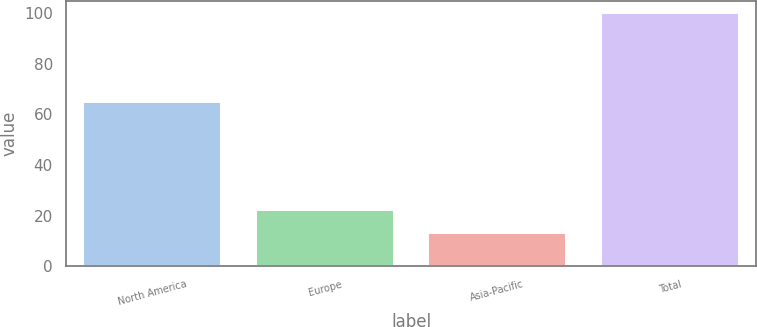Convert chart to OTSL. <chart><loc_0><loc_0><loc_500><loc_500><bar_chart><fcel>North America<fcel>Europe<fcel>Asia-Pacific<fcel>Total<nl><fcel>65<fcel>22<fcel>13<fcel>100<nl></chart> 